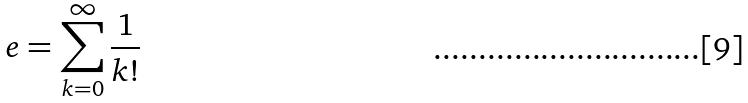<formula> <loc_0><loc_0><loc_500><loc_500>e = \sum _ { k = 0 } ^ { \infty } \frac { 1 } { k ! }</formula> 